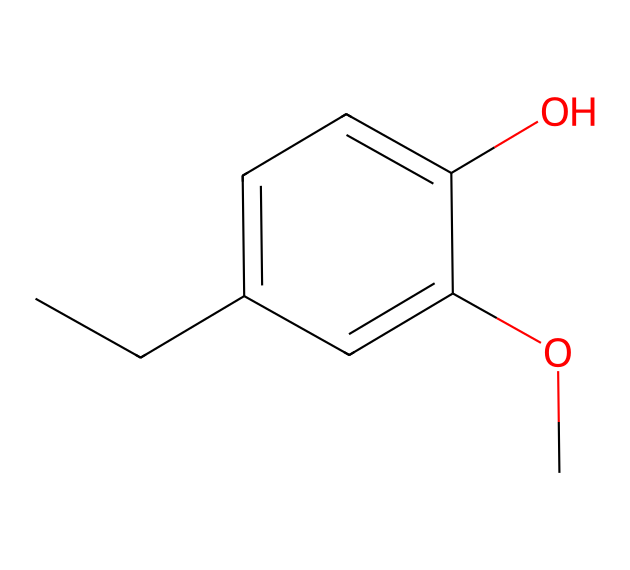What is the chemical name of this compound? The structure represented by the SMILES corresponds to eugenol, a known phenolic compound commonly found in plants and used in various applications including muscle rubs.
Answer: eugenol How many carbon atoms are in eugenol? By analyzing the SMILES representation, the structure contains a total of 10 carbon atoms. This can be counted by identifying each 'C' in the structure as well as noticing the branching and aromatic ring.
Answer: 10 Is there a hydroxyl group in eugenol? The presence of 'O' in the SMILES notation indicates the hydroxyl (-OH) group, typical for phenols. Here, the ‘O’ at the end of the ring confirms the presence of this functional group.
Answer: yes What type of functional group does eugenol contain? Eugenol contains a phenolic hydroxyl group as indicated by the presence of the -OH group attached to the aromatic ring.  Therefore, it is classified under phenolic compounds.
Answer: phenolic Does eugenol have any methoxy groups? The 'OC' within the SMILES indicates the presence of a methoxy group (-OCH3), confirming that eugenol contains this specific functional group.
Answer: yes What is the total number of oxygen atoms in eugenol? Upon examining the chemical structure represented by the SMILES, there are 2 oxygen atoms present: one in the hydroxyl group and one in the methoxy group.
Answer: 2 How many rings are present in eugenol's structure? The presence of a benzene ring in the structure indicates there is one aromatic ring, and since it doesn’t contain any additional cyclic components, there is only one ring.
Answer: 1 